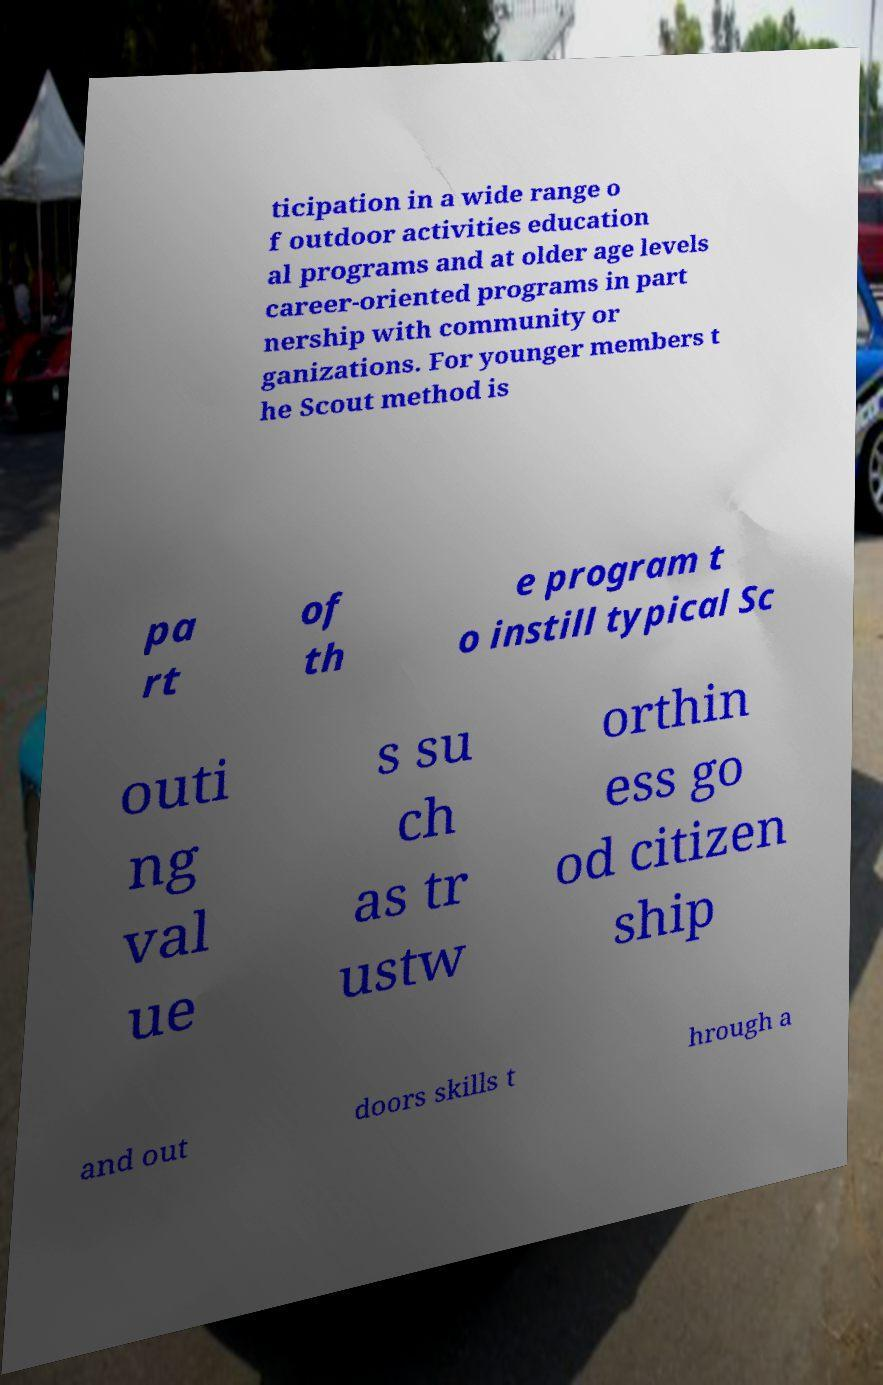There's text embedded in this image that I need extracted. Can you transcribe it verbatim? ticipation in a wide range o f outdoor activities education al programs and at older age levels career-oriented programs in part nership with community or ganizations. For younger members t he Scout method is pa rt of th e program t o instill typical Sc outi ng val ue s su ch as tr ustw orthin ess go od citizen ship and out doors skills t hrough a 